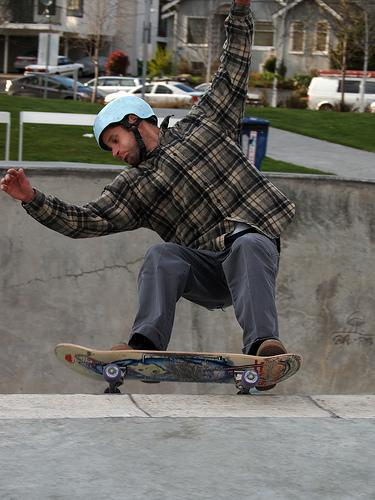What is the main object in the image and what activity is it performing? The main object is a man on a skateboard who is performing a trick in a skateboard park. Is the man on the skateboard wearing proper safety gear? If so, what is it? Yes, the man is wearing proper safety gear which includes a light-colored helmet, likely blue. Can you identify the skateboard's distinct feature and its color? The skateboard has purple wheels on the bottom. What type of clothing is the skateboarder wearing and what color is it? The skateboarder is wearing gray pants and a checked shirt, which could be plaid. How many houses are visible in the image and what are their colors? There are two houses visible in the image, one is blue with white trim and the other is a white two-story house. Analyze the overall atmosphere and sentiment of the image. The image has an energetic and positive atmosphere, capturing a man enjoying his skateboarding trick in a park setting, surrounded by everyday life. Provide a description of the skateboarder's facial features that are visible in the image. The skateboarder's mouth, nose, and eye are visible. The mouth is small, nose is somewhat large, and the eye is well-defined. Give a brief overview of the setting in which the man is skateboarding. The man is skateboarding in a park with a grassy area behind it, while vehicles are parked on the street and houses are visible in the background. List the different objects found in the background of the image. Grassy area, blue trash can, orange ladder, white work van, parked vehicles, red bush, and two houses. Please count the number of vehicles visible in the image and describe their types and colors. There are two vehicles visible: a white work van with a red ladder on top, and parked cars on the street. 